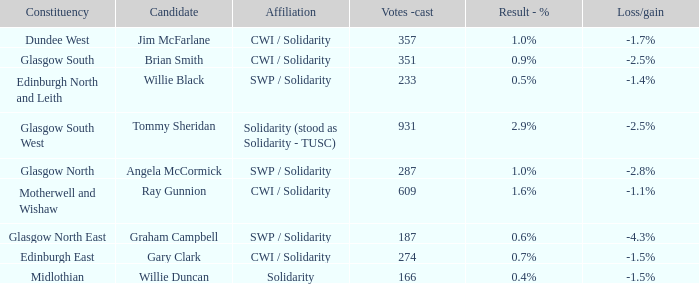When the affiliation was based on unity, what were the losses or gains experienced? -1.5%. 